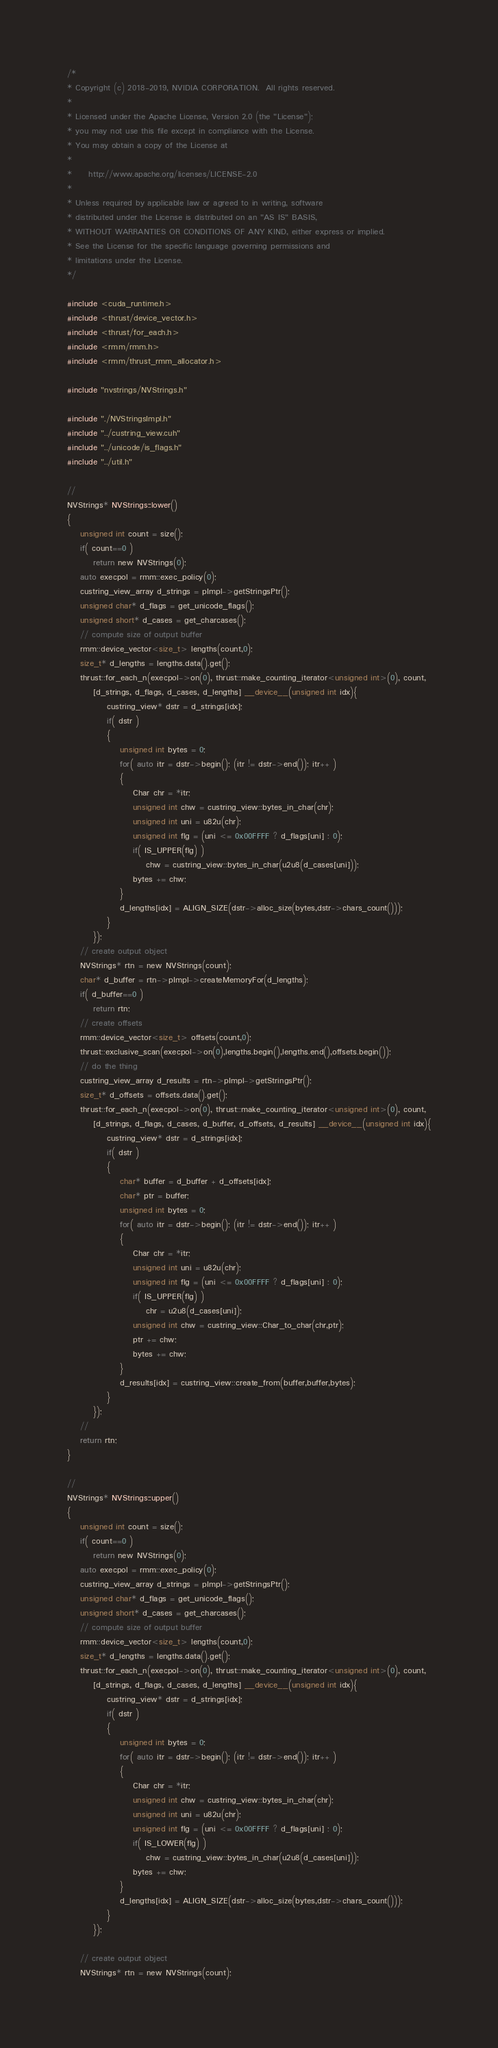Convert code to text. <code><loc_0><loc_0><loc_500><loc_500><_Cuda_>/*
* Copyright (c) 2018-2019, NVIDIA CORPORATION.  All rights reserved.
*
* Licensed under the Apache License, Version 2.0 (the "License");
* you may not use this file except in compliance with the License.
* You may obtain a copy of the License at
*
*     http://www.apache.org/licenses/LICENSE-2.0
*
* Unless required by applicable law or agreed to in writing, software
* distributed under the License is distributed on an "AS IS" BASIS,
* WITHOUT WARRANTIES OR CONDITIONS OF ANY KIND, either express or implied.
* See the License for the specific language governing permissions and
* limitations under the License.
*/

#include <cuda_runtime.h>
#include <thrust/device_vector.h>
#include <thrust/for_each.h>
#include <rmm/rmm.h>
#include <rmm/thrust_rmm_allocator.h>

#include "nvstrings/NVStrings.h"

#include "./NVStringsImpl.h"
#include "../custring_view.cuh"
#include "../unicode/is_flags.h"
#include "../util.h"

//
NVStrings* NVStrings::lower()
{
    unsigned int count = size();
    if( count==0 )
        return new NVStrings(0);
    auto execpol = rmm::exec_policy(0);
    custring_view_array d_strings = pImpl->getStringsPtr();
    unsigned char* d_flags = get_unicode_flags();
    unsigned short* d_cases = get_charcases();
    // compute size of output buffer
    rmm::device_vector<size_t> lengths(count,0);
    size_t* d_lengths = lengths.data().get();
    thrust::for_each_n(execpol->on(0), thrust::make_counting_iterator<unsigned int>(0), count,
        [d_strings, d_flags, d_cases, d_lengths] __device__(unsigned int idx){
            custring_view* dstr = d_strings[idx];
            if( dstr )
            {
                unsigned int bytes = 0;
                for( auto itr = dstr->begin(); (itr != dstr->end()); itr++ )
                {
                    Char chr = *itr;
                    unsigned int chw = custring_view::bytes_in_char(chr);
                    unsigned int uni = u82u(chr);
                    unsigned int flg = (uni <= 0x00FFFF ? d_flags[uni] : 0);
                    if( IS_UPPER(flg) )
                        chw = custring_view::bytes_in_char(u2u8(d_cases[uni]));
                    bytes += chw;
                }
                d_lengths[idx] = ALIGN_SIZE(dstr->alloc_size(bytes,dstr->chars_count()));
            }
        });
    // create output object
    NVStrings* rtn = new NVStrings(count);
    char* d_buffer = rtn->pImpl->createMemoryFor(d_lengths);
    if( d_buffer==0 )
        return rtn;
    // create offsets
    rmm::device_vector<size_t> offsets(count,0);
    thrust::exclusive_scan(execpol->on(0),lengths.begin(),lengths.end(),offsets.begin());
    // do the thing
    custring_view_array d_results = rtn->pImpl->getStringsPtr();
    size_t* d_offsets = offsets.data().get();
    thrust::for_each_n(execpol->on(0), thrust::make_counting_iterator<unsigned int>(0), count,
        [d_strings, d_flags, d_cases, d_buffer, d_offsets, d_results] __device__(unsigned int idx){
            custring_view* dstr = d_strings[idx];
            if( dstr )
            {
                char* buffer = d_buffer + d_offsets[idx];
                char* ptr = buffer;
                unsigned int bytes = 0;
                for( auto itr = dstr->begin(); (itr != dstr->end()); itr++ )
                {
                    Char chr = *itr;
                    unsigned int uni = u82u(chr);
                    unsigned int flg = (uni <= 0x00FFFF ? d_flags[uni] : 0);
                    if( IS_UPPER(flg) )
                        chr = u2u8(d_cases[uni]);
                    unsigned int chw = custring_view::Char_to_char(chr,ptr);
                    ptr += chw;
                    bytes += chw;
                }
                d_results[idx] = custring_view::create_from(buffer,buffer,bytes);
            }
        });
    //
    return rtn;
}

//
NVStrings* NVStrings::upper()
{
    unsigned int count = size();
    if( count==0 )
        return new NVStrings(0);
    auto execpol = rmm::exec_policy(0);
    custring_view_array d_strings = pImpl->getStringsPtr();
    unsigned char* d_flags = get_unicode_flags();
    unsigned short* d_cases = get_charcases();
    // compute size of output buffer
    rmm::device_vector<size_t> lengths(count,0);
    size_t* d_lengths = lengths.data().get();
    thrust::for_each_n(execpol->on(0), thrust::make_counting_iterator<unsigned int>(0), count,
        [d_strings, d_flags, d_cases, d_lengths] __device__(unsigned int idx){
            custring_view* dstr = d_strings[idx];
            if( dstr )
            {
                unsigned int bytes = 0;
                for( auto itr = dstr->begin(); (itr != dstr->end()); itr++ )
                {
                    Char chr = *itr;
                    unsigned int chw = custring_view::bytes_in_char(chr);
                    unsigned int uni = u82u(chr);
                    unsigned int flg = (uni <= 0x00FFFF ? d_flags[uni] : 0);
                    if( IS_LOWER(flg) )
                        chw = custring_view::bytes_in_char(u2u8(d_cases[uni]));
                    bytes += chw;
                }
                d_lengths[idx] = ALIGN_SIZE(dstr->alloc_size(bytes,dstr->chars_count()));
            }
        });

    // create output object
    NVStrings* rtn = new NVStrings(count);</code> 